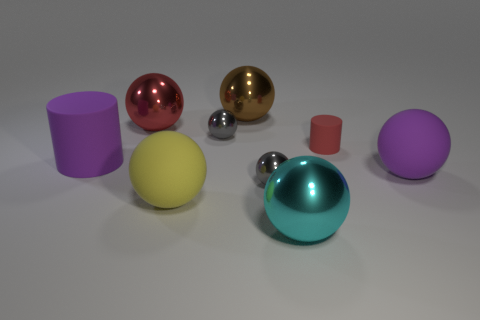Subtract all purple spheres. How many spheres are left? 6 Subtract all large shiny spheres. How many spheres are left? 4 Subtract all red spheres. Subtract all cyan blocks. How many spheres are left? 6 Subtract all cylinders. How many objects are left? 7 Subtract all small rubber things. Subtract all tiny red cylinders. How many objects are left? 7 Add 4 large yellow spheres. How many large yellow spheres are left? 5 Add 2 tiny metallic things. How many tiny metallic things exist? 4 Subtract 2 gray spheres. How many objects are left? 7 